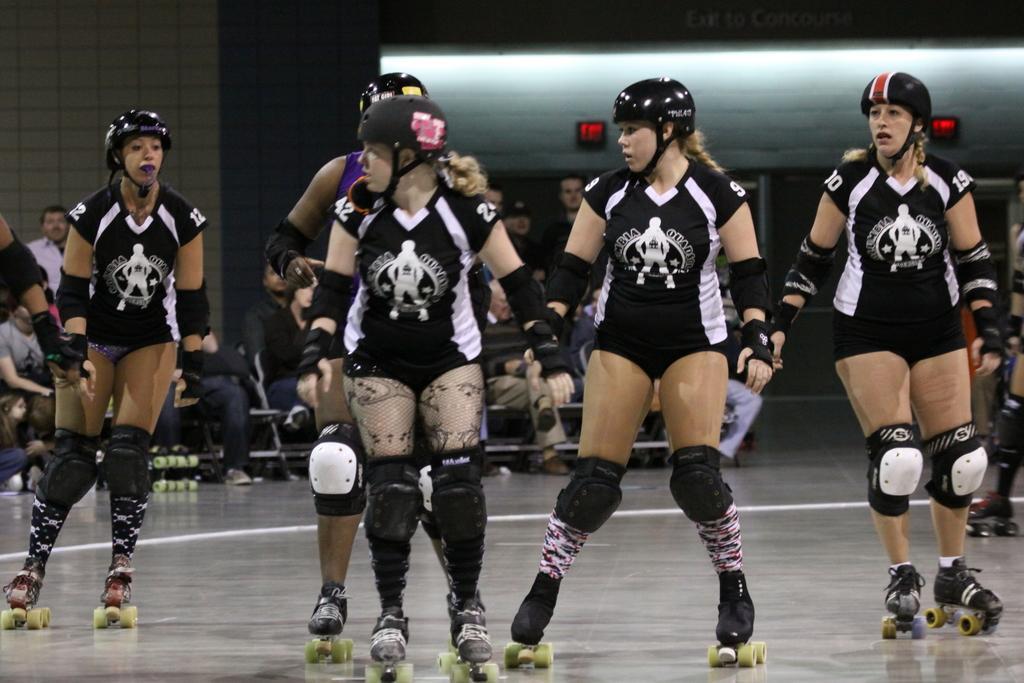Please provide a concise description of this image. In this picture we can see a group of girls wearing a black dress and skating. Behind there are some people sitting and looking at them. In the background we can see the wall and lights. 